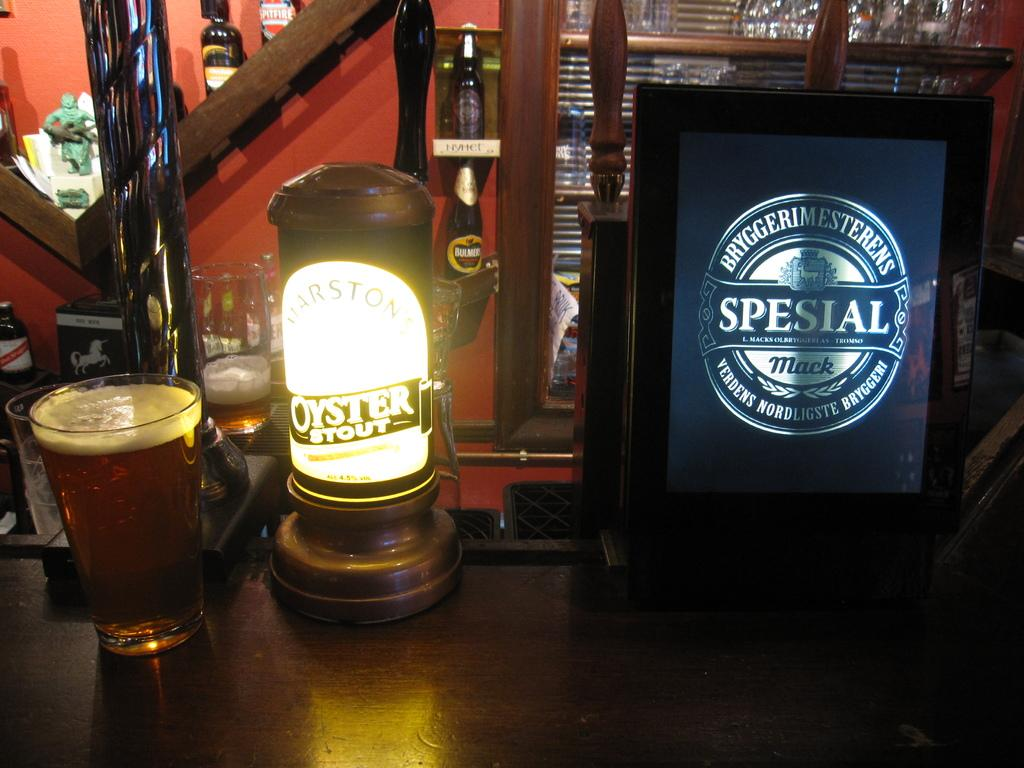<image>
Share a concise interpretation of the image provided. A lantern With the brand Oyster Stout on a table with a glass of beer. 